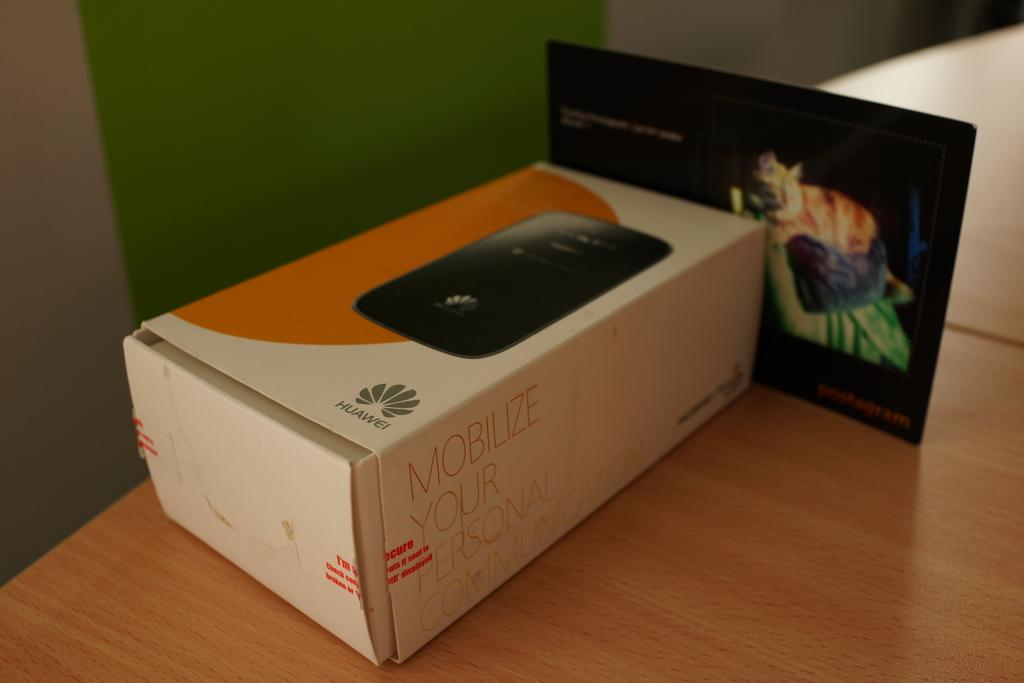<image>
Relay a brief, clear account of the picture shown. A phone in a box that says mobilize your communication. 